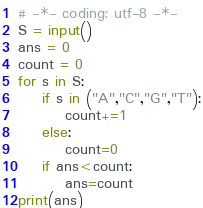Convert code to text. <code><loc_0><loc_0><loc_500><loc_500><_Python_># -*- coding: utf-8 -*-
S = input()
ans = 0
count = 0
for s in S:
    if s in ("A","C","G","T"):
        count+=1
    else:
        count=0
    if ans<count:
        ans=count
print(ans)</code> 